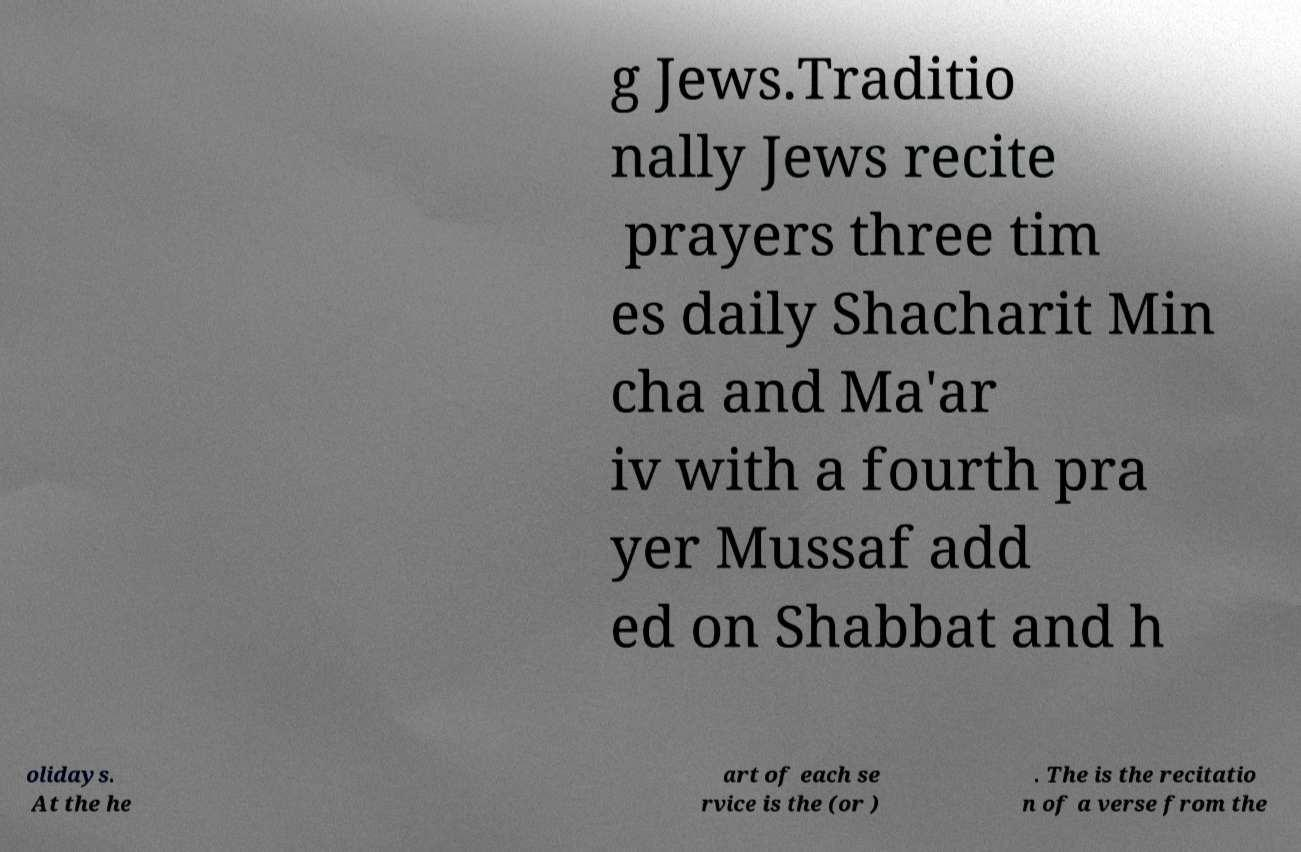I need the written content from this picture converted into text. Can you do that? g Jews.Traditio nally Jews recite prayers three tim es daily Shacharit Min cha and Ma'ar iv with a fourth pra yer Mussaf add ed on Shabbat and h olidays. At the he art of each se rvice is the (or ) . The is the recitatio n of a verse from the 